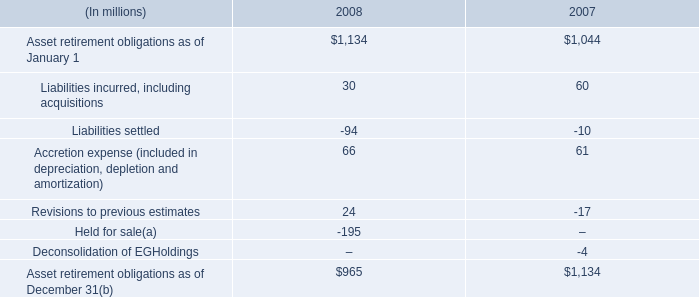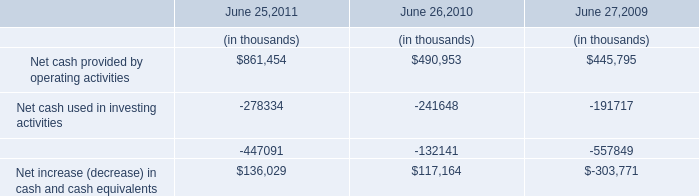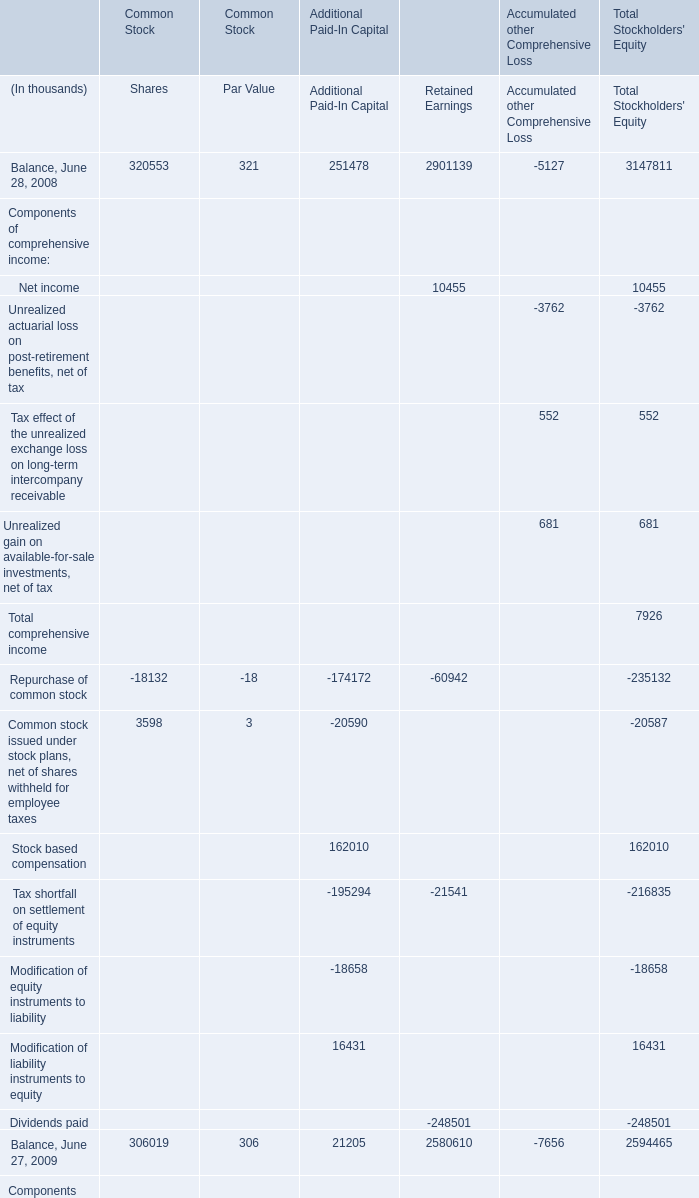What's the greatest value of Retained Earnings in 2008? (in thousand) 
Answer: 2901139. 